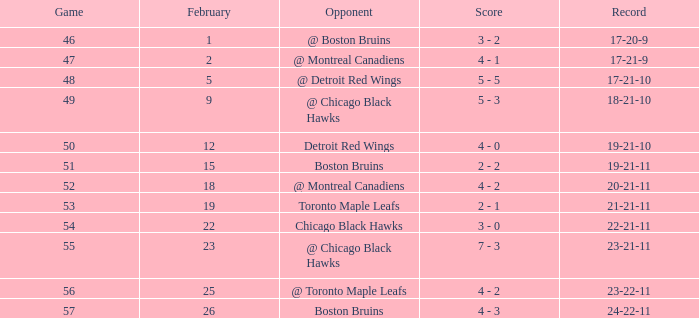What is the tally of the game preceding 56 done post february 18 versus the chicago black hawks? 3 - 0. 